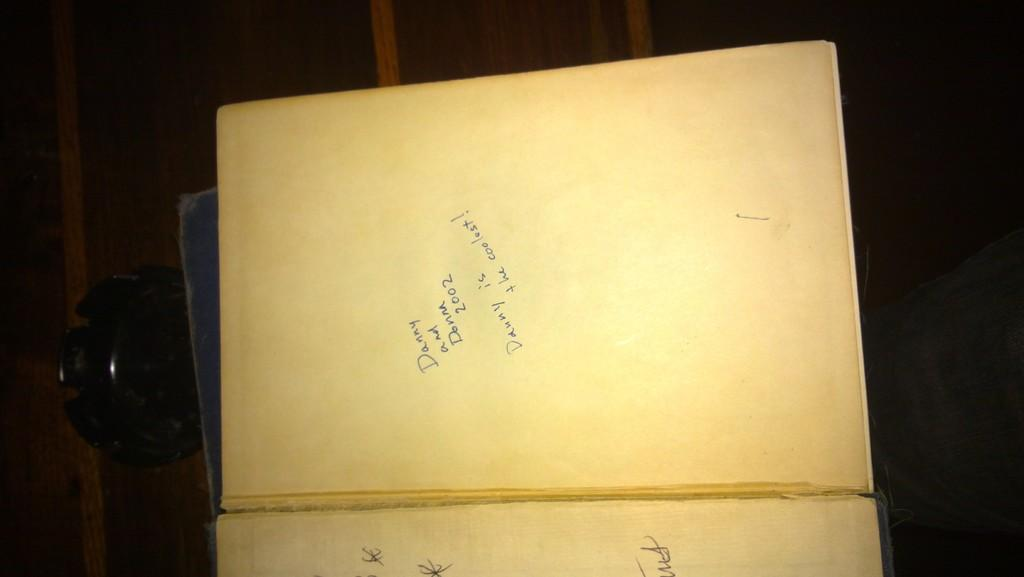What type of objects can be seen in the image? There are books with text in the image. What is present on the table in the image? There is an object on the table in the image. Can you describe any part of a person in the image? The leg of a person is visible on the right side of the image. What type of bears can be seen walking around in the image? There are no bears present in the image. What sign is visible in the image? There is no sign visible in the image. 